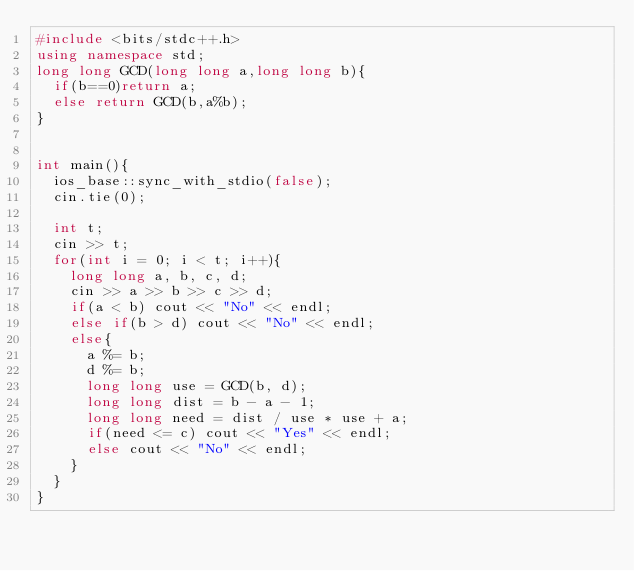Convert code to text. <code><loc_0><loc_0><loc_500><loc_500><_C++_>#include <bits/stdc++.h>
using namespace std;
long long GCD(long long a,long long b){
  if(b==0)return a; 
  else return GCD(b,a%b);
}


int main(){
  ios_base::sync_with_stdio(false);
  cin.tie(0);

  int t;
  cin >> t;
  for(int i = 0; i < t; i++){
    long long a, b, c, d;
    cin >> a >> b >> c >> d;
    if(a < b) cout << "No" << endl;
    else if(b > d) cout << "No" << endl;
    else{
      a %= b;
      d %= b;
      long long use = GCD(b, d);
      long long dist = b - a - 1;
      long long need = dist / use * use + a;
      if(need <= c) cout << "Yes" << endl;
      else cout << "No" << endl;
    }
  }
}</code> 